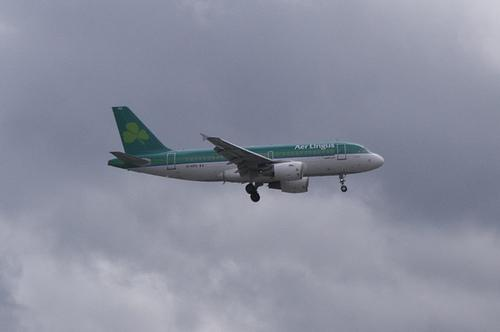Identify the primary object in the image and the action it is performing. An airplane, which is green and white, is flying in a partly cloudy sky. Count the number of wheels on the airplane and describe their position. There are three wheels on the airplane: one front wheel and two back wheels. How many wings are visible on the plane and where are they located? Two wings are visible: the left wing and the tail wing on the plane. What company logo is visible on the airplane and where is it located? A light green shamrock logo is visible on the vertical stabilizer. What is the sentiment portrayed by the image?  The image portrays a sense of freedom and adventure as the airplane flies in the sky. Examine and provide details about the engines on the airplane. There are two engines on the plane: one on the left wing called the left engine, and another called the right engine with a slightly different position. What is the main color of the sky in the image? The sky is primarily gray with patches of blue. What type of airplane is depicted in the image based on its color scheme and logo? The airplane is likely an Aer Lingus aircraft, based on its green and white color scheme and the shamrock logo. Describe the pattern of clouds in the sky. The clouds in the sky are fluffy and scattered throughout, with areas of blue sky visible between them. Analyze the quality of the image in terms of sharpness and contrast. The image quality appears to be satisfactory with a fair level of sharpness and contrast, though not outstanding. Identify the company name present on the airplane. The company name is Aer Lingus. Describe the sentiment invoked by the image. The image feels positive and depicts the advancement of technology in air travel. Is the airplane flying close to the clouds? Yes, the airplane is flying close to the clouds. What is the main color of the airplane? The main color of the airplane is green and white. From the given annotations, which side of the plane has the engine? There are engines on both the left and right side of the plane. Are there any anomalies detected in the plane engines? No anomalies are detected in the plane engines. Do the clouds in the sky look normal or unusual? The clouds in the sky look normal. Describe the structure of the airplane's wings. The airplane has one left wing which is horizontally flattened. What type of clouds are visible in the background? Fluffy clouds are visible in the background. What type of sky is the airplane flying in? The airplane is flying in a partly cloudy sky. How many door annotations are present in the given image? There are 3 door annotations present. How would you describe the airplane's flight path? The plane is flying to the right. Select the correct phrase for the image: "green airplane in the sky" or "snowy mountains near a river". green airplane in the sky What color is the sky in the image? The sky is gray. Count the number of landing gear wheels visible in the picture. There are three landing gear wheels visible. Assess the overall quality of the image. The image is clear with proper object identification and accurate annotations. Pick the correct phrase for the image: "two landing gear wheels" or "one small landing gear wheel." Both phrases are correct, as two landing gear wheels and one small landing gear wheel are visible. Which part of the airplane has the door? The door is on the main body of the airplane. Identify the object present on the tail wing of the plane. There is a green clover on the tail wing. 